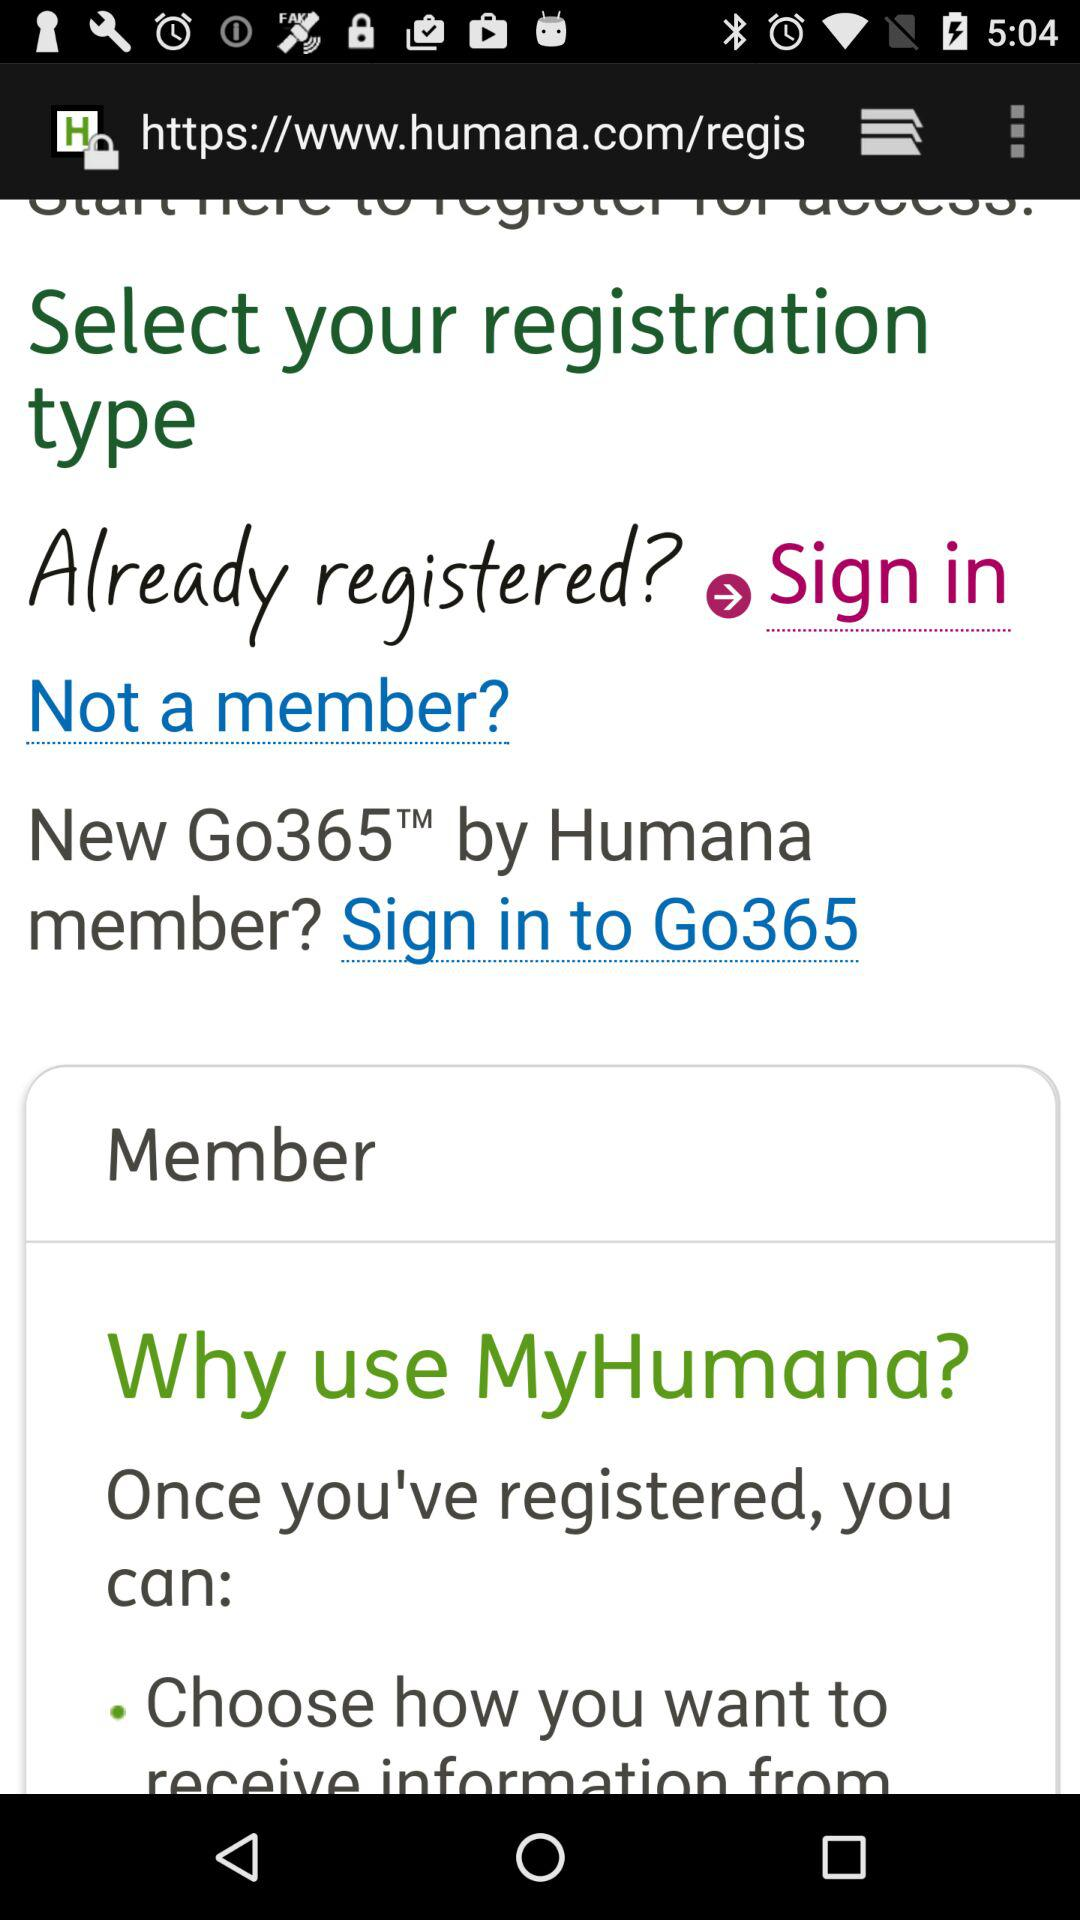What is the username?
When the provided information is insufficient, respond with <no answer>. <no answer> 